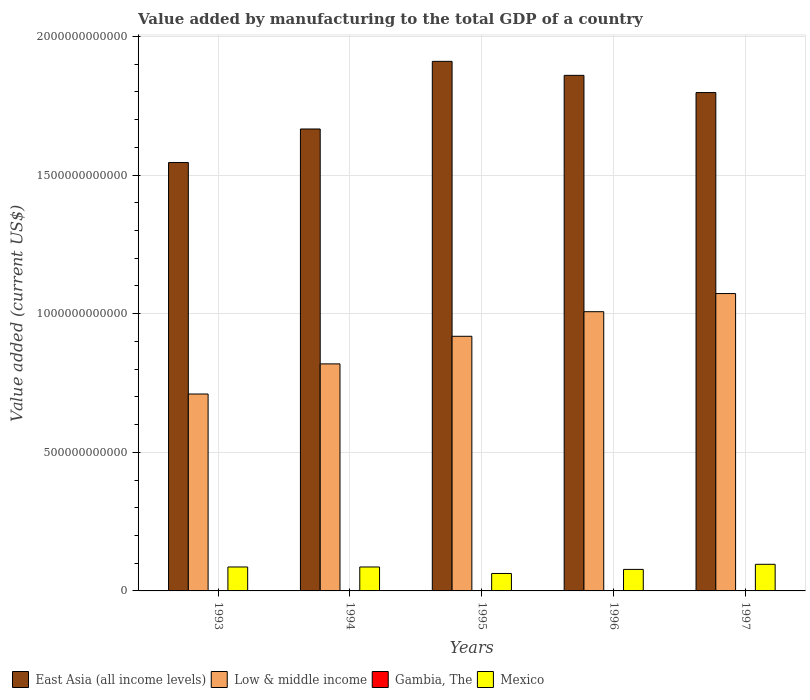How many bars are there on the 1st tick from the right?
Your response must be concise. 4. What is the label of the 4th group of bars from the left?
Keep it short and to the point. 1996. In how many cases, is the number of bars for a given year not equal to the number of legend labels?
Ensure brevity in your answer.  0. What is the value added by manufacturing to the total GDP in Low & middle income in 1996?
Your answer should be very brief. 1.01e+12. Across all years, what is the maximum value added by manufacturing to the total GDP in Mexico?
Keep it short and to the point. 9.60e+1. Across all years, what is the minimum value added by manufacturing to the total GDP in East Asia (all income levels)?
Give a very brief answer. 1.55e+12. In which year was the value added by manufacturing to the total GDP in Mexico maximum?
Offer a very short reply. 1997. What is the total value added by manufacturing to the total GDP in East Asia (all income levels) in the graph?
Provide a succinct answer. 8.78e+12. What is the difference between the value added by manufacturing to the total GDP in Gambia, The in 1995 and that in 1997?
Make the answer very short. -3.73e+05. What is the difference between the value added by manufacturing to the total GDP in Mexico in 1993 and the value added by manufacturing to the total GDP in Gambia, The in 1996?
Make the answer very short. 8.63e+1. What is the average value added by manufacturing to the total GDP in East Asia (all income levels) per year?
Offer a terse response. 1.76e+12. In the year 1997, what is the difference between the value added by manufacturing to the total GDP in Mexico and value added by manufacturing to the total GDP in East Asia (all income levels)?
Provide a succinct answer. -1.70e+12. In how many years, is the value added by manufacturing to the total GDP in Low & middle income greater than 1500000000000 US$?
Your answer should be compact. 0. What is the ratio of the value added by manufacturing to the total GDP in East Asia (all income levels) in 1993 to that in 1997?
Your answer should be compact. 0.86. Is the value added by manufacturing to the total GDP in Mexico in 1995 less than that in 1997?
Your answer should be compact. Yes. What is the difference between the highest and the second highest value added by manufacturing to the total GDP in Low & middle income?
Make the answer very short. 6.54e+1. What is the difference between the highest and the lowest value added by manufacturing to the total GDP in East Asia (all income levels)?
Offer a terse response. 3.65e+11. Is it the case that in every year, the sum of the value added by manufacturing to the total GDP in Gambia, The and value added by manufacturing to the total GDP in Low & middle income is greater than the value added by manufacturing to the total GDP in Mexico?
Your answer should be compact. Yes. How many bars are there?
Provide a short and direct response. 20. What is the difference between two consecutive major ticks on the Y-axis?
Your answer should be very brief. 5.00e+11. Are the values on the major ticks of Y-axis written in scientific E-notation?
Provide a succinct answer. No. Does the graph contain any zero values?
Offer a terse response. No. Where does the legend appear in the graph?
Keep it short and to the point. Bottom left. What is the title of the graph?
Your response must be concise. Value added by manufacturing to the total GDP of a country. What is the label or title of the X-axis?
Provide a succinct answer. Years. What is the label or title of the Y-axis?
Offer a terse response. Value added (current US$). What is the Value added (current US$) of East Asia (all income levels) in 1993?
Provide a succinct answer. 1.55e+12. What is the Value added (current US$) in Low & middle income in 1993?
Offer a very short reply. 7.10e+11. What is the Value added (current US$) of Gambia, The in 1993?
Ensure brevity in your answer.  6.57e+07. What is the Value added (current US$) in Mexico in 1993?
Ensure brevity in your answer.  8.64e+1. What is the Value added (current US$) in East Asia (all income levels) in 1994?
Keep it short and to the point. 1.67e+12. What is the Value added (current US$) of Low & middle income in 1994?
Offer a terse response. 8.19e+11. What is the Value added (current US$) of Gambia, The in 1994?
Make the answer very short. 5.99e+07. What is the Value added (current US$) of Mexico in 1994?
Provide a short and direct response. 8.64e+1. What is the Value added (current US$) in East Asia (all income levels) in 1995?
Provide a short and direct response. 1.91e+12. What is the Value added (current US$) in Low & middle income in 1995?
Make the answer very short. 9.19e+11. What is the Value added (current US$) in Gambia, The in 1995?
Your answer should be compact. 6.41e+07. What is the Value added (current US$) of Mexico in 1995?
Provide a succinct answer. 6.29e+1. What is the Value added (current US$) of East Asia (all income levels) in 1996?
Give a very brief answer. 1.86e+12. What is the Value added (current US$) of Low & middle income in 1996?
Keep it short and to the point. 1.01e+12. What is the Value added (current US$) in Gambia, The in 1996?
Your answer should be compact. 6.42e+07. What is the Value added (current US$) of Mexico in 1996?
Provide a short and direct response. 7.76e+1. What is the Value added (current US$) in East Asia (all income levels) in 1997?
Provide a succinct answer. 1.80e+12. What is the Value added (current US$) of Low & middle income in 1997?
Keep it short and to the point. 1.07e+12. What is the Value added (current US$) in Gambia, The in 1997?
Keep it short and to the point. 6.45e+07. What is the Value added (current US$) of Mexico in 1997?
Give a very brief answer. 9.60e+1. Across all years, what is the maximum Value added (current US$) of East Asia (all income levels)?
Offer a very short reply. 1.91e+12. Across all years, what is the maximum Value added (current US$) of Low & middle income?
Keep it short and to the point. 1.07e+12. Across all years, what is the maximum Value added (current US$) in Gambia, The?
Provide a succinct answer. 6.57e+07. Across all years, what is the maximum Value added (current US$) in Mexico?
Your answer should be compact. 9.60e+1. Across all years, what is the minimum Value added (current US$) of East Asia (all income levels)?
Provide a short and direct response. 1.55e+12. Across all years, what is the minimum Value added (current US$) in Low & middle income?
Make the answer very short. 7.10e+11. Across all years, what is the minimum Value added (current US$) in Gambia, The?
Ensure brevity in your answer.  5.99e+07. Across all years, what is the minimum Value added (current US$) in Mexico?
Offer a terse response. 6.29e+1. What is the total Value added (current US$) of East Asia (all income levels) in the graph?
Provide a short and direct response. 8.78e+12. What is the total Value added (current US$) in Low & middle income in the graph?
Your answer should be compact. 4.53e+12. What is the total Value added (current US$) in Gambia, The in the graph?
Provide a short and direct response. 3.18e+08. What is the total Value added (current US$) of Mexico in the graph?
Offer a terse response. 4.09e+11. What is the difference between the Value added (current US$) in East Asia (all income levels) in 1993 and that in 1994?
Provide a short and direct response. -1.21e+11. What is the difference between the Value added (current US$) of Low & middle income in 1993 and that in 1994?
Offer a very short reply. -1.09e+11. What is the difference between the Value added (current US$) of Gambia, The in 1993 and that in 1994?
Provide a succinct answer. 5.82e+06. What is the difference between the Value added (current US$) of Mexico in 1993 and that in 1994?
Give a very brief answer. 2.60e+07. What is the difference between the Value added (current US$) in East Asia (all income levels) in 1993 and that in 1995?
Make the answer very short. -3.65e+11. What is the difference between the Value added (current US$) of Low & middle income in 1993 and that in 1995?
Make the answer very short. -2.08e+11. What is the difference between the Value added (current US$) in Gambia, The in 1993 and that in 1995?
Keep it short and to the point. 1.64e+06. What is the difference between the Value added (current US$) of Mexico in 1993 and that in 1995?
Offer a terse response. 2.35e+1. What is the difference between the Value added (current US$) in East Asia (all income levels) in 1993 and that in 1996?
Provide a short and direct response. -3.14e+11. What is the difference between the Value added (current US$) of Low & middle income in 1993 and that in 1996?
Your answer should be compact. -2.97e+11. What is the difference between the Value added (current US$) of Gambia, The in 1993 and that in 1996?
Offer a terse response. 1.47e+06. What is the difference between the Value added (current US$) in Mexico in 1993 and that in 1996?
Provide a short and direct response. 8.76e+09. What is the difference between the Value added (current US$) in East Asia (all income levels) in 1993 and that in 1997?
Provide a succinct answer. -2.52e+11. What is the difference between the Value added (current US$) in Low & middle income in 1993 and that in 1997?
Your response must be concise. -3.62e+11. What is the difference between the Value added (current US$) in Gambia, The in 1993 and that in 1997?
Provide a succinct answer. 1.27e+06. What is the difference between the Value added (current US$) of Mexico in 1993 and that in 1997?
Make the answer very short. -9.63e+09. What is the difference between the Value added (current US$) in East Asia (all income levels) in 1994 and that in 1995?
Offer a very short reply. -2.44e+11. What is the difference between the Value added (current US$) in Low & middle income in 1994 and that in 1995?
Make the answer very short. -9.95e+1. What is the difference between the Value added (current US$) in Gambia, The in 1994 and that in 1995?
Provide a succinct answer. -4.18e+06. What is the difference between the Value added (current US$) in Mexico in 1994 and that in 1995?
Your answer should be very brief. 2.34e+1. What is the difference between the Value added (current US$) in East Asia (all income levels) in 1994 and that in 1996?
Give a very brief answer. -1.93e+11. What is the difference between the Value added (current US$) of Low & middle income in 1994 and that in 1996?
Offer a terse response. -1.88e+11. What is the difference between the Value added (current US$) of Gambia, The in 1994 and that in 1996?
Your answer should be compact. -4.35e+06. What is the difference between the Value added (current US$) in Mexico in 1994 and that in 1996?
Give a very brief answer. 8.73e+09. What is the difference between the Value added (current US$) in East Asia (all income levels) in 1994 and that in 1997?
Ensure brevity in your answer.  -1.31e+11. What is the difference between the Value added (current US$) of Low & middle income in 1994 and that in 1997?
Your response must be concise. -2.54e+11. What is the difference between the Value added (current US$) of Gambia, The in 1994 and that in 1997?
Offer a terse response. -4.55e+06. What is the difference between the Value added (current US$) of Mexico in 1994 and that in 1997?
Make the answer very short. -9.66e+09. What is the difference between the Value added (current US$) of East Asia (all income levels) in 1995 and that in 1996?
Provide a short and direct response. 5.05e+1. What is the difference between the Value added (current US$) of Low & middle income in 1995 and that in 1996?
Offer a terse response. -8.87e+1. What is the difference between the Value added (current US$) in Gambia, The in 1995 and that in 1996?
Provide a succinct answer. -1.69e+05. What is the difference between the Value added (current US$) in Mexico in 1995 and that in 1996?
Ensure brevity in your answer.  -1.47e+1. What is the difference between the Value added (current US$) of East Asia (all income levels) in 1995 and that in 1997?
Give a very brief answer. 1.13e+11. What is the difference between the Value added (current US$) of Low & middle income in 1995 and that in 1997?
Your answer should be compact. -1.54e+11. What is the difference between the Value added (current US$) of Gambia, The in 1995 and that in 1997?
Make the answer very short. -3.73e+05. What is the difference between the Value added (current US$) in Mexico in 1995 and that in 1997?
Your response must be concise. -3.31e+1. What is the difference between the Value added (current US$) in East Asia (all income levels) in 1996 and that in 1997?
Your answer should be very brief. 6.21e+1. What is the difference between the Value added (current US$) in Low & middle income in 1996 and that in 1997?
Offer a very short reply. -6.54e+1. What is the difference between the Value added (current US$) of Gambia, The in 1996 and that in 1997?
Ensure brevity in your answer.  -2.04e+05. What is the difference between the Value added (current US$) in Mexico in 1996 and that in 1997?
Your answer should be very brief. -1.84e+1. What is the difference between the Value added (current US$) of East Asia (all income levels) in 1993 and the Value added (current US$) of Low & middle income in 1994?
Make the answer very short. 7.26e+11. What is the difference between the Value added (current US$) of East Asia (all income levels) in 1993 and the Value added (current US$) of Gambia, The in 1994?
Provide a short and direct response. 1.55e+12. What is the difference between the Value added (current US$) of East Asia (all income levels) in 1993 and the Value added (current US$) of Mexico in 1994?
Keep it short and to the point. 1.46e+12. What is the difference between the Value added (current US$) of Low & middle income in 1993 and the Value added (current US$) of Gambia, The in 1994?
Your response must be concise. 7.10e+11. What is the difference between the Value added (current US$) in Low & middle income in 1993 and the Value added (current US$) in Mexico in 1994?
Your answer should be compact. 6.24e+11. What is the difference between the Value added (current US$) of Gambia, The in 1993 and the Value added (current US$) of Mexico in 1994?
Offer a terse response. -8.63e+1. What is the difference between the Value added (current US$) in East Asia (all income levels) in 1993 and the Value added (current US$) in Low & middle income in 1995?
Keep it short and to the point. 6.27e+11. What is the difference between the Value added (current US$) of East Asia (all income levels) in 1993 and the Value added (current US$) of Gambia, The in 1995?
Make the answer very short. 1.55e+12. What is the difference between the Value added (current US$) of East Asia (all income levels) in 1993 and the Value added (current US$) of Mexico in 1995?
Your answer should be compact. 1.48e+12. What is the difference between the Value added (current US$) in Low & middle income in 1993 and the Value added (current US$) in Gambia, The in 1995?
Your response must be concise. 7.10e+11. What is the difference between the Value added (current US$) in Low & middle income in 1993 and the Value added (current US$) in Mexico in 1995?
Give a very brief answer. 6.47e+11. What is the difference between the Value added (current US$) in Gambia, The in 1993 and the Value added (current US$) in Mexico in 1995?
Your answer should be very brief. -6.28e+1. What is the difference between the Value added (current US$) in East Asia (all income levels) in 1993 and the Value added (current US$) in Low & middle income in 1996?
Make the answer very short. 5.38e+11. What is the difference between the Value added (current US$) of East Asia (all income levels) in 1993 and the Value added (current US$) of Gambia, The in 1996?
Ensure brevity in your answer.  1.55e+12. What is the difference between the Value added (current US$) of East Asia (all income levels) in 1993 and the Value added (current US$) of Mexico in 1996?
Offer a very short reply. 1.47e+12. What is the difference between the Value added (current US$) of Low & middle income in 1993 and the Value added (current US$) of Gambia, The in 1996?
Your answer should be compact. 7.10e+11. What is the difference between the Value added (current US$) in Low & middle income in 1993 and the Value added (current US$) in Mexico in 1996?
Keep it short and to the point. 6.33e+11. What is the difference between the Value added (current US$) of Gambia, The in 1993 and the Value added (current US$) of Mexico in 1996?
Keep it short and to the point. -7.76e+1. What is the difference between the Value added (current US$) of East Asia (all income levels) in 1993 and the Value added (current US$) of Low & middle income in 1997?
Offer a very short reply. 4.73e+11. What is the difference between the Value added (current US$) of East Asia (all income levels) in 1993 and the Value added (current US$) of Gambia, The in 1997?
Offer a terse response. 1.55e+12. What is the difference between the Value added (current US$) of East Asia (all income levels) in 1993 and the Value added (current US$) of Mexico in 1997?
Provide a short and direct response. 1.45e+12. What is the difference between the Value added (current US$) of Low & middle income in 1993 and the Value added (current US$) of Gambia, The in 1997?
Your response must be concise. 7.10e+11. What is the difference between the Value added (current US$) of Low & middle income in 1993 and the Value added (current US$) of Mexico in 1997?
Provide a succinct answer. 6.14e+11. What is the difference between the Value added (current US$) in Gambia, The in 1993 and the Value added (current US$) in Mexico in 1997?
Offer a terse response. -9.60e+1. What is the difference between the Value added (current US$) in East Asia (all income levels) in 1994 and the Value added (current US$) in Low & middle income in 1995?
Offer a very short reply. 7.48e+11. What is the difference between the Value added (current US$) in East Asia (all income levels) in 1994 and the Value added (current US$) in Gambia, The in 1995?
Your answer should be very brief. 1.67e+12. What is the difference between the Value added (current US$) in East Asia (all income levels) in 1994 and the Value added (current US$) in Mexico in 1995?
Offer a very short reply. 1.60e+12. What is the difference between the Value added (current US$) of Low & middle income in 1994 and the Value added (current US$) of Gambia, The in 1995?
Make the answer very short. 8.19e+11. What is the difference between the Value added (current US$) in Low & middle income in 1994 and the Value added (current US$) in Mexico in 1995?
Offer a terse response. 7.56e+11. What is the difference between the Value added (current US$) in Gambia, The in 1994 and the Value added (current US$) in Mexico in 1995?
Your answer should be very brief. -6.29e+1. What is the difference between the Value added (current US$) in East Asia (all income levels) in 1994 and the Value added (current US$) in Low & middle income in 1996?
Provide a short and direct response. 6.59e+11. What is the difference between the Value added (current US$) of East Asia (all income levels) in 1994 and the Value added (current US$) of Gambia, The in 1996?
Provide a succinct answer. 1.67e+12. What is the difference between the Value added (current US$) of East Asia (all income levels) in 1994 and the Value added (current US$) of Mexico in 1996?
Ensure brevity in your answer.  1.59e+12. What is the difference between the Value added (current US$) of Low & middle income in 1994 and the Value added (current US$) of Gambia, The in 1996?
Provide a succinct answer. 8.19e+11. What is the difference between the Value added (current US$) of Low & middle income in 1994 and the Value added (current US$) of Mexico in 1996?
Offer a terse response. 7.41e+11. What is the difference between the Value added (current US$) in Gambia, The in 1994 and the Value added (current US$) in Mexico in 1996?
Make the answer very short. -7.76e+1. What is the difference between the Value added (current US$) in East Asia (all income levels) in 1994 and the Value added (current US$) in Low & middle income in 1997?
Provide a short and direct response. 5.94e+11. What is the difference between the Value added (current US$) of East Asia (all income levels) in 1994 and the Value added (current US$) of Gambia, The in 1997?
Your answer should be very brief. 1.67e+12. What is the difference between the Value added (current US$) in East Asia (all income levels) in 1994 and the Value added (current US$) in Mexico in 1997?
Your response must be concise. 1.57e+12. What is the difference between the Value added (current US$) in Low & middle income in 1994 and the Value added (current US$) in Gambia, The in 1997?
Provide a succinct answer. 8.19e+11. What is the difference between the Value added (current US$) of Low & middle income in 1994 and the Value added (current US$) of Mexico in 1997?
Offer a terse response. 7.23e+11. What is the difference between the Value added (current US$) of Gambia, The in 1994 and the Value added (current US$) of Mexico in 1997?
Give a very brief answer. -9.60e+1. What is the difference between the Value added (current US$) of East Asia (all income levels) in 1995 and the Value added (current US$) of Low & middle income in 1996?
Your response must be concise. 9.03e+11. What is the difference between the Value added (current US$) in East Asia (all income levels) in 1995 and the Value added (current US$) in Gambia, The in 1996?
Offer a very short reply. 1.91e+12. What is the difference between the Value added (current US$) of East Asia (all income levels) in 1995 and the Value added (current US$) of Mexico in 1996?
Your answer should be compact. 1.83e+12. What is the difference between the Value added (current US$) of Low & middle income in 1995 and the Value added (current US$) of Gambia, The in 1996?
Offer a very short reply. 9.18e+11. What is the difference between the Value added (current US$) in Low & middle income in 1995 and the Value added (current US$) in Mexico in 1996?
Provide a succinct answer. 8.41e+11. What is the difference between the Value added (current US$) in Gambia, The in 1995 and the Value added (current US$) in Mexico in 1996?
Your response must be concise. -7.76e+1. What is the difference between the Value added (current US$) in East Asia (all income levels) in 1995 and the Value added (current US$) in Low & middle income in 1997?
Your answer should be compact. 8.38e+11. What is the difference between the Value added (current US$) of East Asia (all income levels) in 1995 and the Value added (current US$) of Gambia, The in 1997?
Offer a very short reply. 1.91e+12. What is the difference between the Value added (current US$) of East Asia (all income levels) in 1995 and the Value added (current US$) of Mexico in 1997?
Your answer should be very brief. 1.81e+12. What is the difference between the Value added (current US$) in Low & middle income in 1995 and the Value added (current US$) in Gambia, The in 1997?
Provide a succinct answer. 9.18e+11. What is the difference between the Value added (current US$) in Low & middle income in 1995 and the Value added (current US$) in Mexico in 1997?
Your response must be concise. 8.23e+11. What is the difference between the Value added (current US$) in Gambia, The in 1995 and the Value added (current US$) in Mexico in 1997?
Give a very brief answer. -9.60e+1. What is the difference between the Value added (current US$) in East Asia (all income levels) in 1996 and the Value added (current US$) in Low & middle income in 1997?
Make the answer very short. 7.87e+11. What is the difference between the Value added (current US$) in East Asia (all income levels) in 1996 and the Value added (current US$) in Gambia, The in 1997?
Offer a very short reply. 1.86e+12. What is the difference between the Value added (current US$) in East Asia (all income levels) in 1996 and the Value added (current US$) in Mexico in 1997?
Give a very brief answer. 1.76e+12. What is the difference between the Value added (current US$) in Low & middle income in 1996 and the Value added (current US$) in Gambia, The in 1997?
Offer a very short reply. 1.01e+12. What is the difference between the Value added (current US$) of Low & middle income in 1996 and the Value added (current US$) of Mexico in 1997?
Your answer should be compact. 9.11e+11. What is the difference between the Value added (current US$) in Gambia, The in 1996 and the Value added (current US$) in Mexico in 1997?
Offer a terse response. -9.60e+1. What is the average Value added (current US$) in East Asia (all income levels) per year?
Offer a terse response. 1.76e+12. What is the average Value added (current US$) of Low & middle income per year?
Your response must be concise. 9.06e+11. What is the average Value added (current US$) in Gambia, The per year?
Make the answer very short. 6.37e+07. What is the average Value added (current US$) of Mexico per year?
Your answer should be very brief. 8.19e+1. In the year 1993, what is the difference between the Value added (current US$) of East Asia (all income levels) and Value added (current US$) of Low & middle income?
Offer a terse response. 8.35e+11. In the year 1993, what is the difference between the Value added (current US$) of East Asia (all income levels) and Value added (current US$) of Gambia, The?
Your answer should be very brief. 1.55e+12. In the year 1993, what is the difference between the Value added (current US$) of East Asia (all income levels) and Value added (current US$) of Mexico?
Offer a terse response. 1.46e+12. In the year 1993, what is the difference between the Value added (current US$) in Low & middle income and Value added (current US$) in Gambia, The?
Offer a terse response. 7.10e+11. In the year 1993, what is the difference between the Value added (current US$) of Low & middle income and Value added (current US$) of Mexico?
Give a very brief answer. 6.24e+11. In the year 1993, what is the difference between the Value added (current US$) of Gambia, The and Value added (current US$) of Mexico?
Offer a very short reply. -8.63e+1. In the year 1994, what is the difference between the Value added (current US$) in East Asia (all income levels) and Value added (current US$) in Low & middle income?
Make the answer very short. 8.47e+11. In the year 1994, what is the difference between the Value added (current US$) in East Asia (all income levels) and Value added (current US$) in Gambia, The?
Make the answer very short. 1.67e+12. In the year 1994, what is the difference between the Value added (current US$) in East Asia (all income levels) and Value added (current US$) in Mexico?
Keep it short and to the point. 1.58e+12. In the year 1994, what is the difference between the Value added (current US$) of Low & middle income and Value added (current US$) of Gambia, The?
Provide a short and direct response. 8.19e+11. In the year 1994, what is the difference between the Value added (current US$) of Low & middle income and Value added (current US$) of Mexico?
Keep it short and to the point. 7.33e+11. In the year 1994, what is the difference between the Value added (current US$) in Gambia, The and Value added (current US$) in Mexico?
Offer a terse response. -8.63e+1. In the year 1995, what is the difference between the Value added (current US$) in East Asia (all income levels) and Value added (current US$) in Low & middle income?
Give a very brief answer. 9.92e+11. In the year 1995, what is the difference between the Value added (current US$) of East Asia (all income levels) and Value added (current US$) of Gambia, The?
Your response must be concise. 1.91e+12. In the year 1995, what is the difference between the Value added (current US$) of East Asia (all income levels) and Value added (current US$) of Mexico?
Your response must be concise. 1.85e+12. In the year 1995, what is the difference between the Value added (current US$) in Low & middle income and Value added (current US$) in Gambia, The?
Your response must be concise. 9.18e+11. In the year 1995, what is the difference between the Value added (current US$) of Low & middle income and Value added (current US$) of Mexico?
Your response must be concise. 8.56e+11. In the year 1995, what is the difference between the Value added (current US$) in Gambia, The and Value added (current US$) in Mexico?
Provide a succinct answer. -6.28e+1. In the year 1996, what is the difference between the Value added (current US$) of East Asia (all income levels) and Value added (current US$) of Low & middle income?
Give a very brief answer. 8.53e+11. In the year 1996, what is the difference between the Value added (current US$) in East Asia (all income levels) and Value added (current US$) in Gambia, The?
Ensure brevity in your answer.  1.86e+12. In the year 1996, what is the difference between the Value added (current US$) of East Asia (all income levels) and Value added (current US$) of Mexico?
Offer a terse response. 1.78e+12. In the year 1996, what is the difference between the Value added (current US$) in Low & middle income and Value added (current US$) in Gambia, The?
Give a very brief answer. 1.01e+12. In the year 1996, what is the difference between the Value added (current US$) of Low & middle income and Value added (current US$) of Mexico?
Keep it short and to the point. 9.30e+11. In the year 1996, what is the difference between the Value added (current US$) in Gambia, The and Value added (current US$) in Mexico?
Offer a terse response. -7.76e+1. In the year 1997, what is the difference between the Value added (current US$) of East Asia (all income levels) and Value added (current US$) of Low & middle income?
Give a very brief answer. 7.25e+11. In the year 1997, what is the difference between the Value added (current US$) in East Asia (all income levels) and Value added (current US$) in Gambia, The?
Your answer should be compact. 1.80e+12. In the year 1997, what is the difference between the Value added (current US$) of East Asia (all income levels) and Value added (current US$) of Mexico?
Ensure brevity in your answer.  1.70e+12. In the year 1997, what is the difference between the Value added (current US$) of Low & middle income and Value added (current US$) of Gambia, The?
Your answer should be very brief. 1.07e+12. In the year 1997, what is the difference between the Value added (current US$) of Low & middle income and Value added (current US$) of Mexico?
Your answer should be very brief. 9.77e+11. In the year 1997, what is the difference between the Value added (current US$) of Gambia, The and Value added (current US$) of Mexico?
Ensure brevity in your answer.  -9.60e+1. What is the ratio of the Value added (current US$) in East Asia (all income levels) in 1993 to that in 1994?
Make the answer very short. 0.93. What is the ratio of the Value added (current US$) of Low & middle income in 1993 to that in 1994?
Ensure brevity in your answer.  0.87. What is the ratio of the Value added (current US$) of Gambia, The in 1993 to that in 1994?
Ensure brevity in your answer.  1.1. What is the ratio of the Value added (current US$) of East Asia (all income levels) in 1993 to that in 1995?
Offer a very short reply. 0.81. What is the ratio of the Value added (current US$) of Low & middle income in 1993 to that in 1995?
Offer a terse response. 0.77. What is the ratio of the Value added (current US$) of Gambia, The in 1993 to that in 1995?
Your response must be concise. 1.03. What is the ratio of the Value added (current US$) of Mexico in 1993 to that in 1995?
Give a very brief answer. 1.37. What is the ratio of the Value added (current US$) in East Asia (all income levels) in 1993 to that in 1996?
Offer a terse response. 0.83. What is the ratio of the Value added (current US$) in Low & middle income in 1993 to that in 1996?
Offer a terse response. 0.71. What is the ratio of the Value added (current US$) in Gambia, The in 1993 to that in 1996?
Give a very brief answer. 1.02. What is the ratio of the Value added (current US$) of Mexico in 1993 to that in 1996?
Your response must be concise. 1.11. What is the ratio of the Value added (current US$) of East Asia (all income levels) in 1993 to that in 1997?
Offer a terse response. 0.86. What is the ratio of the Value added (current US$) of Low & middle income in 1993 to that in 1997?
Keep it short and to the point. 0.66. What is the ratio of the Value added (current US$) in Gambia, The in 1993 to that in 1997?
Your response must be concise. 1.02. What is the ratio of the Value added (current US$) of Mexico in 1993 to that in 1997?
Offer a very short reply. 0.9. What is the ratio of the Value added (current US$) of East Asia (all income levels) in 1994 to that in 1995?
Offer a very short reply. 0.87. What is the ratio of the Value added (current US$) of Low & middle income in 1994 to that in 1995?
Provide a succinct answer. 0.89. What is the ratio of the Value added (current US$) in Gambia, The in 1994 to that in 1995?
Offer a terse response. 0.93. What is the ratio of the Value added (current US$) in Mexico in 1994 to that in 1995?
Ensure brevity in your answer.  1.37. What is the ratio of the Value added (current US$) of East Asia (all income levels) in 1994 to that in 1996?
Offer a very short reply. 0.9. What is the ratio of the Value added (current US$) in Low & middle income in 1994 to that in 1996?
Your answer should be compact. 0.81. What is the ratio of the Value added (current US$) of Gambia, The in 1994 to that in 1996?
Your response must be concise. 0.93. What is the ratio of the Value added (current US$) in Mexico in 1994 to that in 1996?
Provide a succinct answer. 1.11. What is the ratio of the Value added (current US$) in East Asia (all income levels) in 1994 to that in 1997?
Make the answer very short. 0.93. What is the ratio of the Value added (current US$) of Low & middle income in 1994 to that in 1997?
Your answer should be very brief. 0.76. What is the ratio of the Value added (current US$) in Gambia, The in 1994 to that in 1997?
Offer a terse response. 0.93. What is the ratio of the Value added (current US$) in Mexico in 1994 to that in 1997?
Provide a short and direct response. 0.9. What is the ratio of the Value added (current US$) of East Asia (all income levels) in 1995 to that in 1996?
Give a very brief answer. 1.03. What is the ratio of the Value added (current US$) in Low & middle income in 1995 to that in 1996?
Make the answer very short. 0.91. What is the ratio of the Value added (current US$) in Gambia, The in 1995 to that in 1996?
Your answer should be very brief. 1. What is the ratio of the Value added (current US$) of Mexico in 1995 to that in 1996?
Your answer should be very brief. 0.81. What is the ratio of the Value added (current US$) of East Asia (all income levels) in 1995 to that in 1997?
Provide a short and direct response. 1.06. What is the ratio of the Value added (current US$) in Low & middle income in 1995 to that in 1997?
Keep it short and to the point. 0.86. What is the ratio of the Value added (current US$) in Gambia, The in 1995 to that in 1997?
Make the answer very short. 0.99. What is the ratio of the Value added (current US$) of Mexico in 1995 to that in 1997?
Offer a terse response. 0.66. What is the ratio of the Value added (current US$) of East Asia (all income levels) in 1996 to that in 1997?
Keep it short and to the point. 1.03. What is the ratio of the Value added (current US$) in Low & middle income in 1996 to that in 1997?
Provide a short and direct response. 0.94. What is the ratio of the Value added (current US$) in Mexico in 1996 to that in 1997?
Offer a very short reply. 0.81. What is the difference between the highest and the second highest Value added (current US$) in East Asia (all income levels)?
Ensure brevity in your answer.  5.05e+1. What is the difference between the highest and the second highest Value added (current US$) of Low & middle income?
Offer a very short reply. 6.54e+1. What is the difference between the highest and the second highest Value added (current US$) in Gambia, The?
Your answer should be very brief. 1.27e+06. What is the difference between the highest and the second highest Value added (current US$) of Mexico?
Provide a short and direct response. 9.63e+09. What is the difference between the highest and the lowest Value added (current US$) of East Asia (all income levels)?
Offer a very short reply. 3.65e+11. What is the difference between the highest and the lowest Value added (current US$) in Low & middle income?
Your answer should be very brief. 3.62e+11. What is the difference between the highest and the lowest Value added (current US$) in Gambia, The?
Offer a terse response. 5.82e+06. What is the difference between the highest and the lowest Value added (current US$) of Mexico?
Your response must be concise. 3.31e+1. 